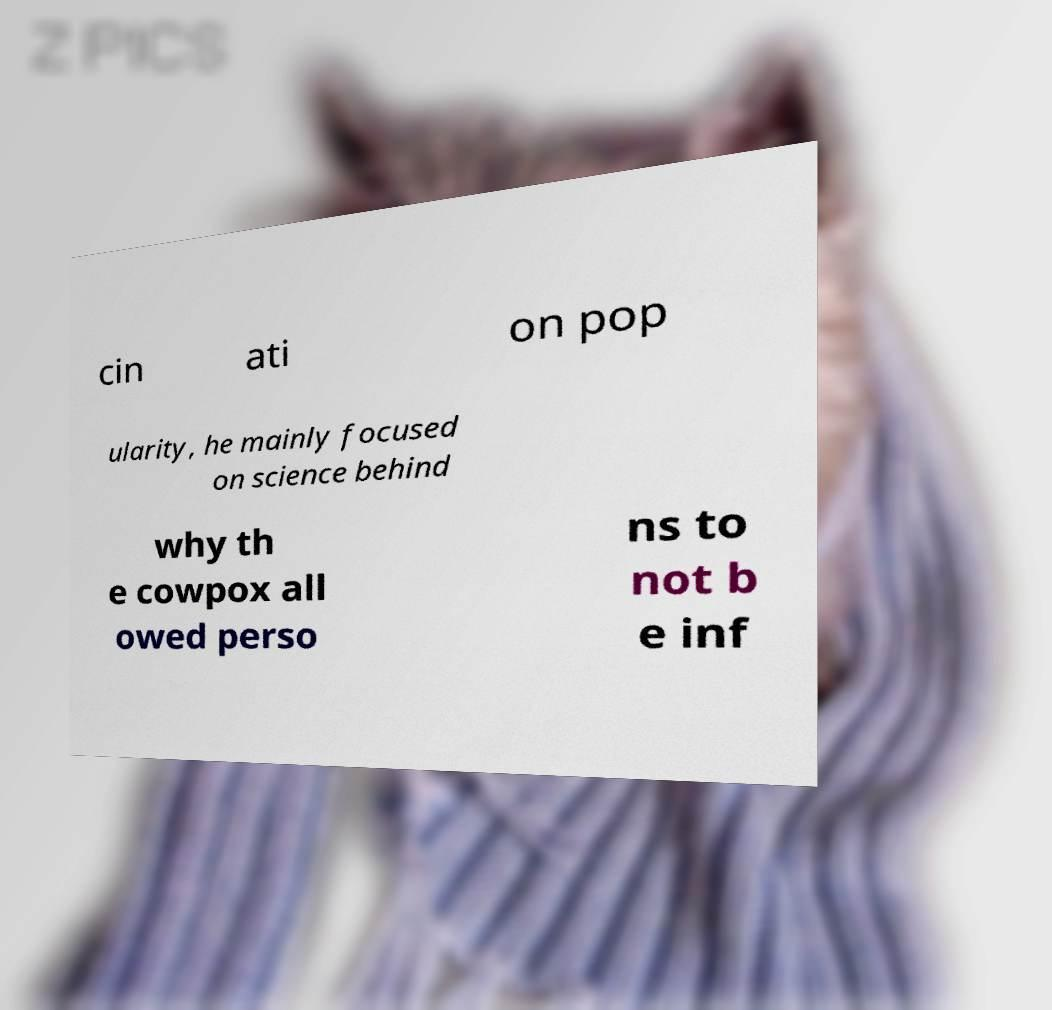For documentation purposes, I need the text within this image transcribed. Could you provide that? cin ati on pop ularity, he mainly focused on science behind why th e cowpox all owed perso ns to not b e inf 